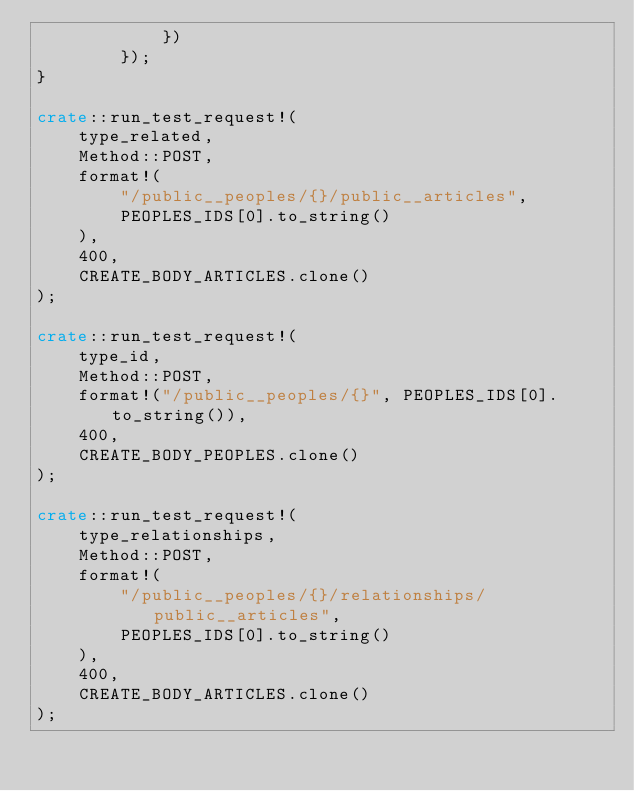Convert code to text. <code><loc_0><loc_0><loc_500><loc_500><_Rust_>            })
        });
}

crate::run_test_request!(
    type_related,
    Method::POST,
    format!(
        "/public__peoples/{}/public__articles",
        PEOPLES_IDS[0].to_string()
    ),
    400,
    CREATE_BODY_ARTICLES.clone()
);

crate::run_test_request!(
    type_id,
    Method::POST,
    format!("/public__peoples/{}", PEOPLES_IDS[0].to_string()),
    400,
    CREATE_BODY_PEOPLES.clone()
);

crate::run_test_request!(
    type_relationships,
    Method::POST,
    format!(
        "/public__peoples/{}/relationships/public__articles",
        PEOPLES_IDS[0].to_string()
    ),
    400,
    CREATE_BODY_ARTICLES.clone()
);
</code> 